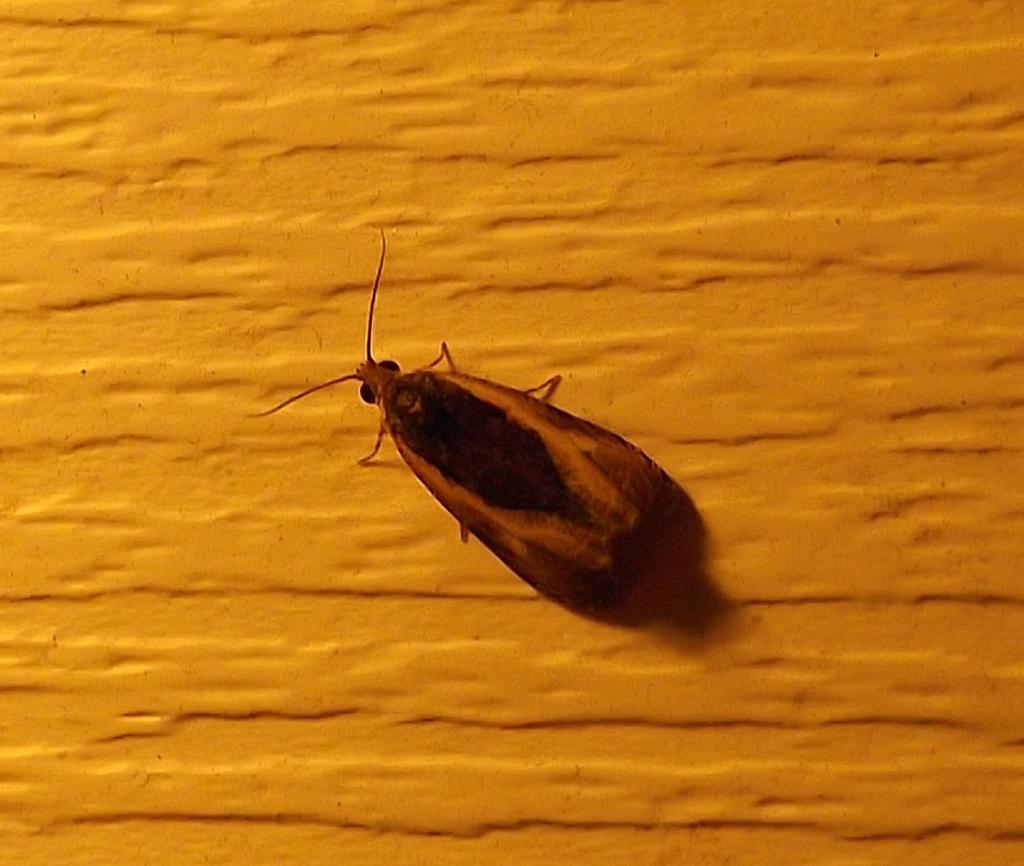In one or two sentences, can you explain what this image depicts? In this image in the center there is one cockroach, in the background there is a wall. 